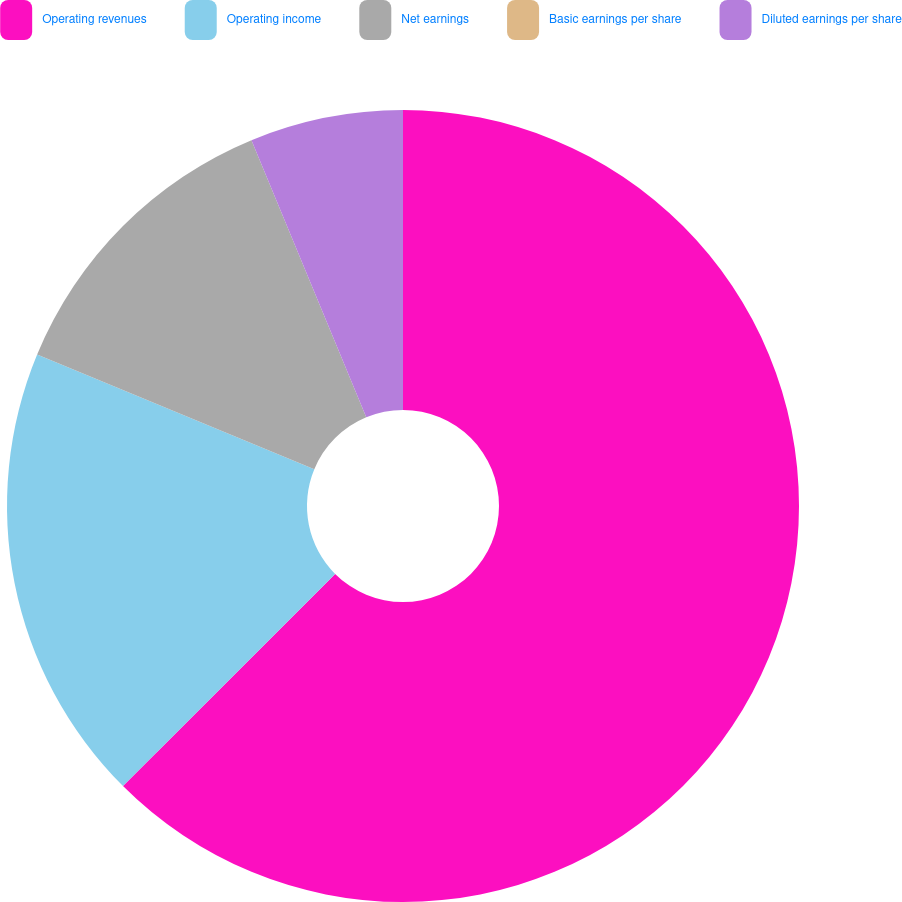<chart> <loc_0><loc_0><loc_500><loc_500><pie_chart><fcel>Operating revenues<fcel>Operating income<fcel>Net earnings<fcel>Basic earnings per share<fcel>Diluted earnings per share<nl><fcel>62.5%<fcel>18.75%<fcel>12.5%<fcel>0.0%<fcel>6.25%<nl></chart> 